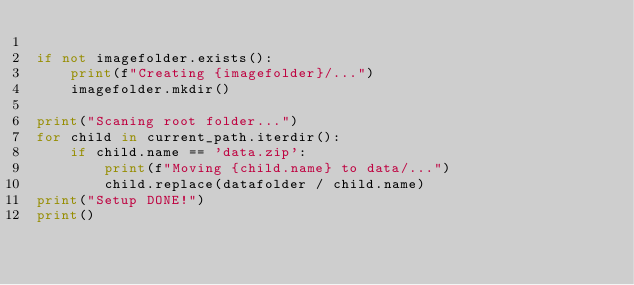<code> <loc_0><loc_0><loc_500><loc_500><_Python_>
if not imagefolder.exists():
    print(f"Creating {imagefolder}/...")
    imagefolder.mkdir()

print("Scaning root folder...")
for child in current_path.iterdir():
    if child.name == 'data.zip':
        print(f"Moving {child.name} to data/...")
        child.replace(datafolder / child.name)
print("Setup DONE!")
print()
</code> 